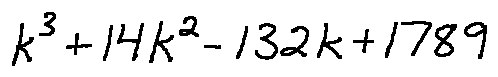<formula> <loc_0><loc_0><loc_500><loc_500>k ^ { 3 } + 1 4 k ^ { 2 } - 1 3 2 k + 1 7 8 9</formula> 